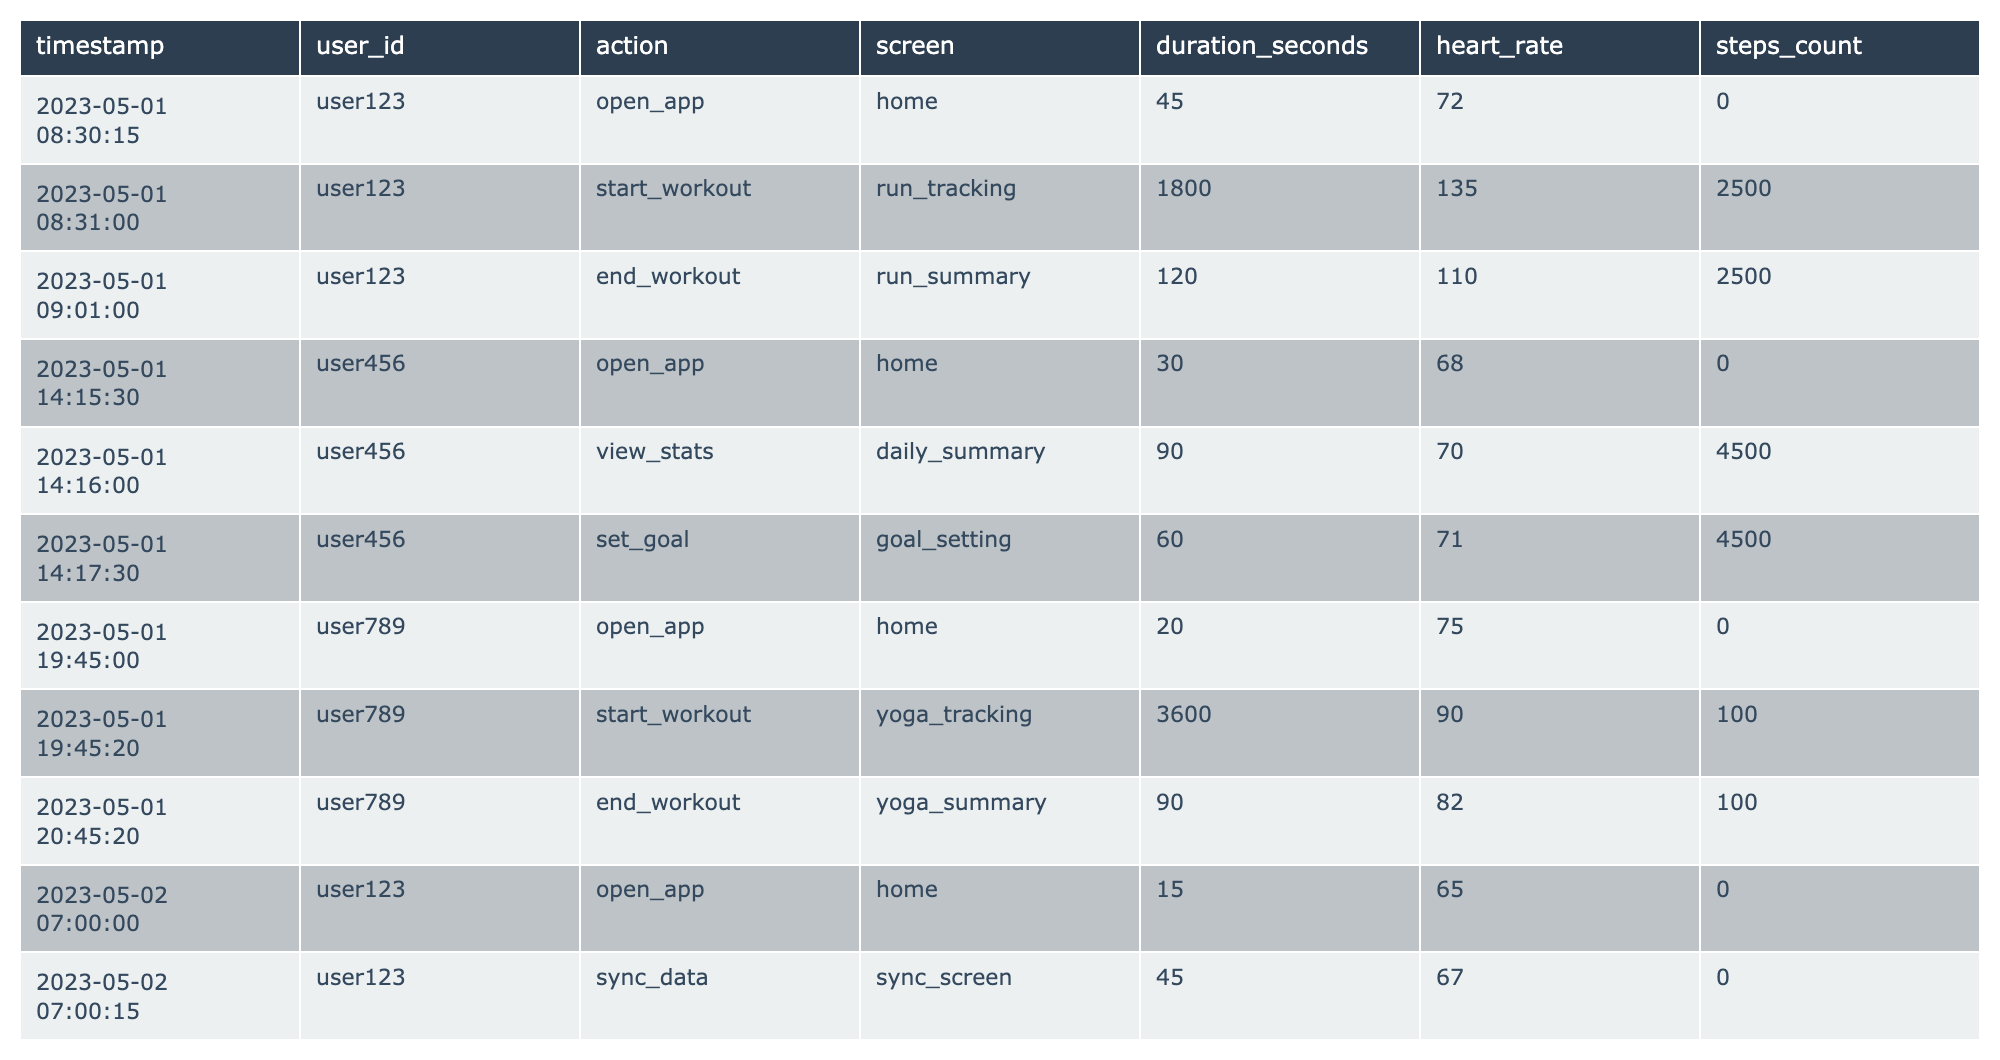What action did user123 take at 08:30:15? According to the table, user123 performed the action "open_app" at the timestamp 08:30:15 on May 1, 2023.
Answer: open_app How long did user456 spend on the daily_summary screen? User456 spent 90 seconds on the daily_summary screen, as indicated by the duration_seconds column for that action.
Answer: 90 seconds What was the heart rate of user789 during their yoga workout? The heart rate of user789 during the yoga workout, which started at 19:45:20, was 90 bpm, as shown in the heart_rate column associated with that action.
Answer: 90 bpm How many steps did user456 accumulate after their swimming workout? User456 accumulated 0 steps after the swimming workout because the steps_count recorded during the swim was 0.
Answer: 0 steps Did user789 set any goals during their session on May 1? Based on the table, user789 did not take any action related to setting goals during their session on May 1, as there is no corresponding entry for that action.
Answer: No What was the average heart rate of user123 across all their recorded actions? User123 had three heart rates: 72 bpm when opening the app, 135 bpm during the workout, and 110 bpm after it. The average is (72 + 135 + 110) / 3 = 105.67 bpm, rounded to two decimal places.
Answer: 105.67 bpm How long was the total active time for user456 across their workout sessions on May 2? User456 had two workout durations: 2700 seconds (45 minutes) for swimming and 60 seconds (1 minute) for the swim summary. Adding them gives a total of 2700 + 60 = 2760 seconds, which equals 46 minutes.
Answer: 2760 seconds Which user had the highest heart rate recorded in the table, and what was it? User123 had the highest heart rate recorded at 135 bpm during their workout, compared to the heart rates of user456 and user789.
Answer: User123, 135 bpm Which user had the longest workout session, and how long was it? User789 had the longest workout session lasting 3600 seconds (1 hour) while doing yoga.
Answer: User789, 3600 seconds What was the total number of steps counted by user456 after their workout sessions on May 2? User456 did not accumulate any steps during their workouts on May 2, as shown by the steps_count which was 0 for both swimming and its summary.
Answer: 0 steps 